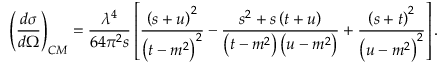Convert formula to latex. <formula><loc_0><loc_0><loc_500><loc_500>\left ( \frac { d \sigma } { d \Omega } \right ) _ { C M } = \frac { \lambda ^ { 4 } } { 6 4 \pi ^ { 2 } s } \left [ \frac { \left ( s + u \right ) ^ { 2 } } { \left ( t - m ^ { 2 } \right ) ^ { 2 } } - \frac { s ^ { 2 } + s \left ( t + u \right ) } { \left ( t - m ^ { 2 } \right ) \left ( u - m ^ { 2 } \right ) } + \frac { \left ( s + t \right ) ^ { 2 } } { \left ( u - m ^ { 2 } \right ) ^ { 2 } } \right ] .</formula> 